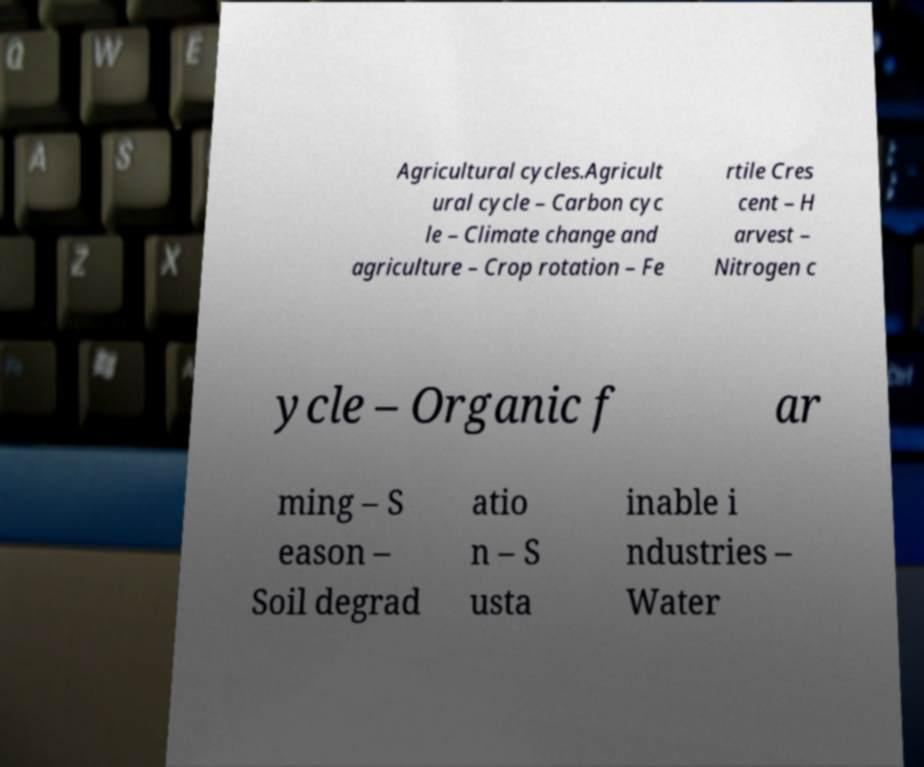Could you extract and type out the text from this image? Agricultural cycles.Agricult ural cycle – Carbon cyc le – Climate change and agriculture – Crop rotation – Fe rtile Cres cent – H arvest – Nitrogen c ycle – Organic f ar ming – S eason – Soil degrad atio n – S usta inable i ndustries – Water 